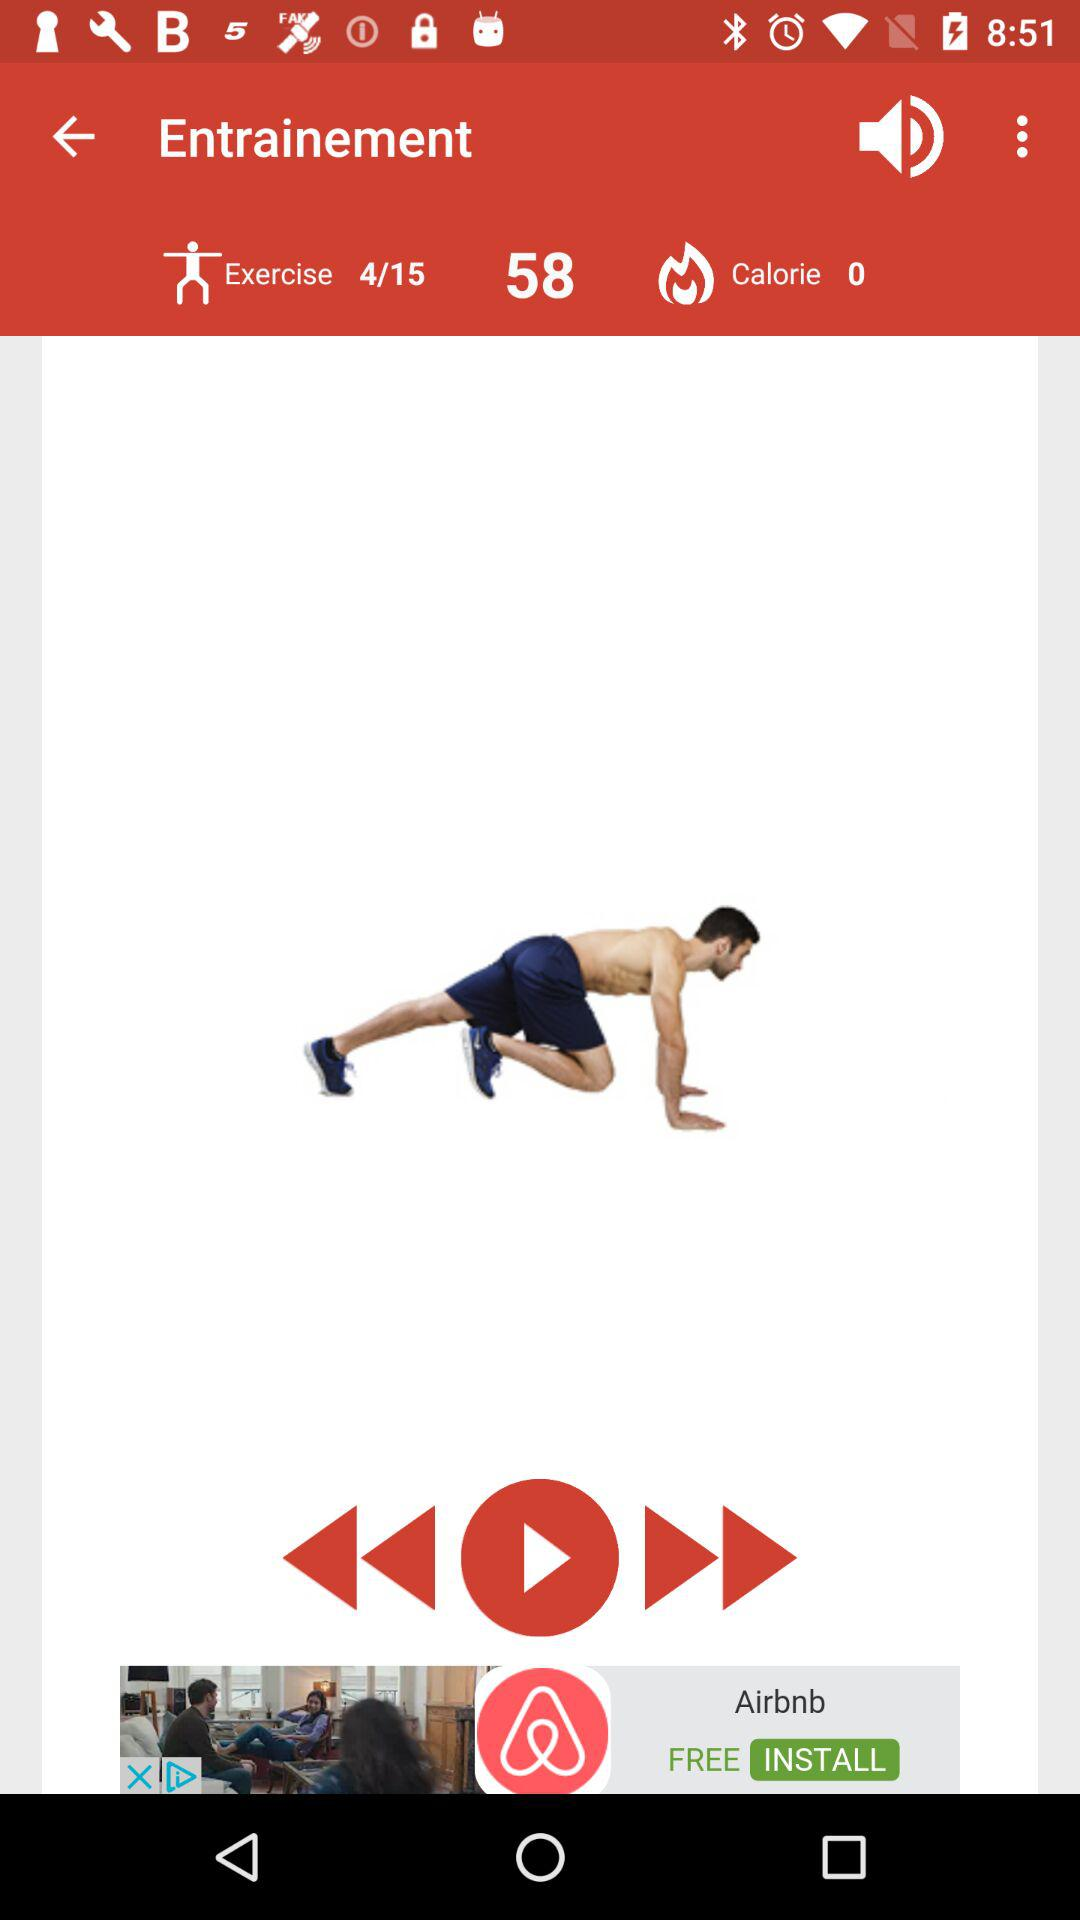How many calories have been burned? There are 0 calories that have been burned. 